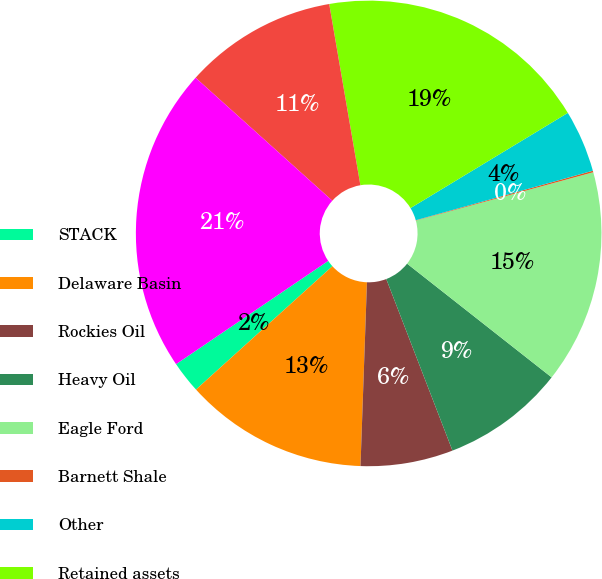Convert chart. <chart><loc_0><loc_0><loc_500><loc_500><pie_chart><fcel>STACK<fcel>Delaware Basin<fcel>Rockies Oil<fcel>Heavy Oil<fcel>Eagle Ford<fcel>Barnett Shale<fcel>Other<fcel>Retained assets<fcel>Divested assets<fcel>Total Oil<nl><fcel>2.21%<fcel>12.74%<fcel>6.42%<fcel>8.53%<fcel>14.84%<fcel>0.11%<fcel>4.32%<fcel>19.05%<fcel>10.63%<fcel>21.15%<nl></chart> 